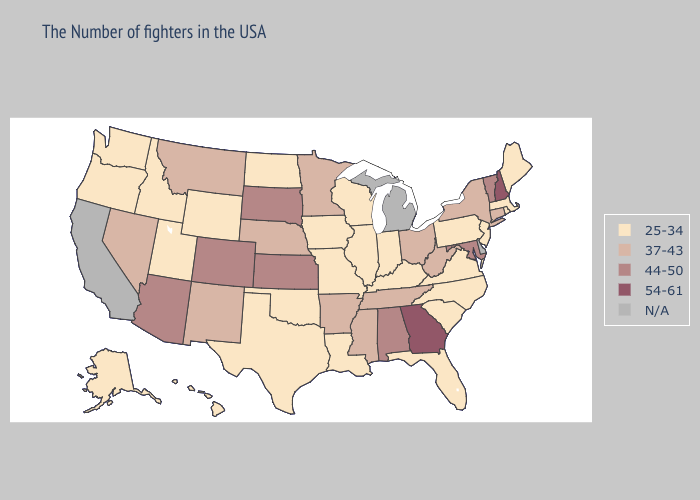Does the map have missing data?
Quick response, please. Yes. Does Pennsylvania have the highest value in the Northeast?
Keep it brief. No. Does South Dakota have the lowest value in the MidWest?
Keep it brief. No. What is the value of Nebraska?
Quick response, please. 37-43. How many symbols are there in the legend?
Quick response, please. 5. What is the value of Virginia?
Be succinct. 25-34. Name the states that have a value in the range 37-43?
Give a very brief answer. Connecticut, New York, West Virginia, Ohio, Tennessee, Mississippi, Arkansas, Minnesota, Nebraska, New Mexico, Montana, Nevada. Name the states that have a value in the range 54-61?
Write a very short answer. New Hampshire, Georgia. How many symbols are there in the legend?
Keep it brief. 5. Among the states that border Utah , does Arizona have the highest value?
Write a very short answer. Yes. Name the states that have a value in the range N/A?
Answer briefly. Delaware, Michigan, California. Which states have the highest value in the USA?
Give a very brief answer. New Hampshire, Georgia. Does South Dakota have the lowest value in the USA?
Write a very short answer. No. What is the value of Pennsylvania?
Be succinct. 25-34. Among the states that border New Mexico , does Texas have the highest value?
Write a very short answer. No. 